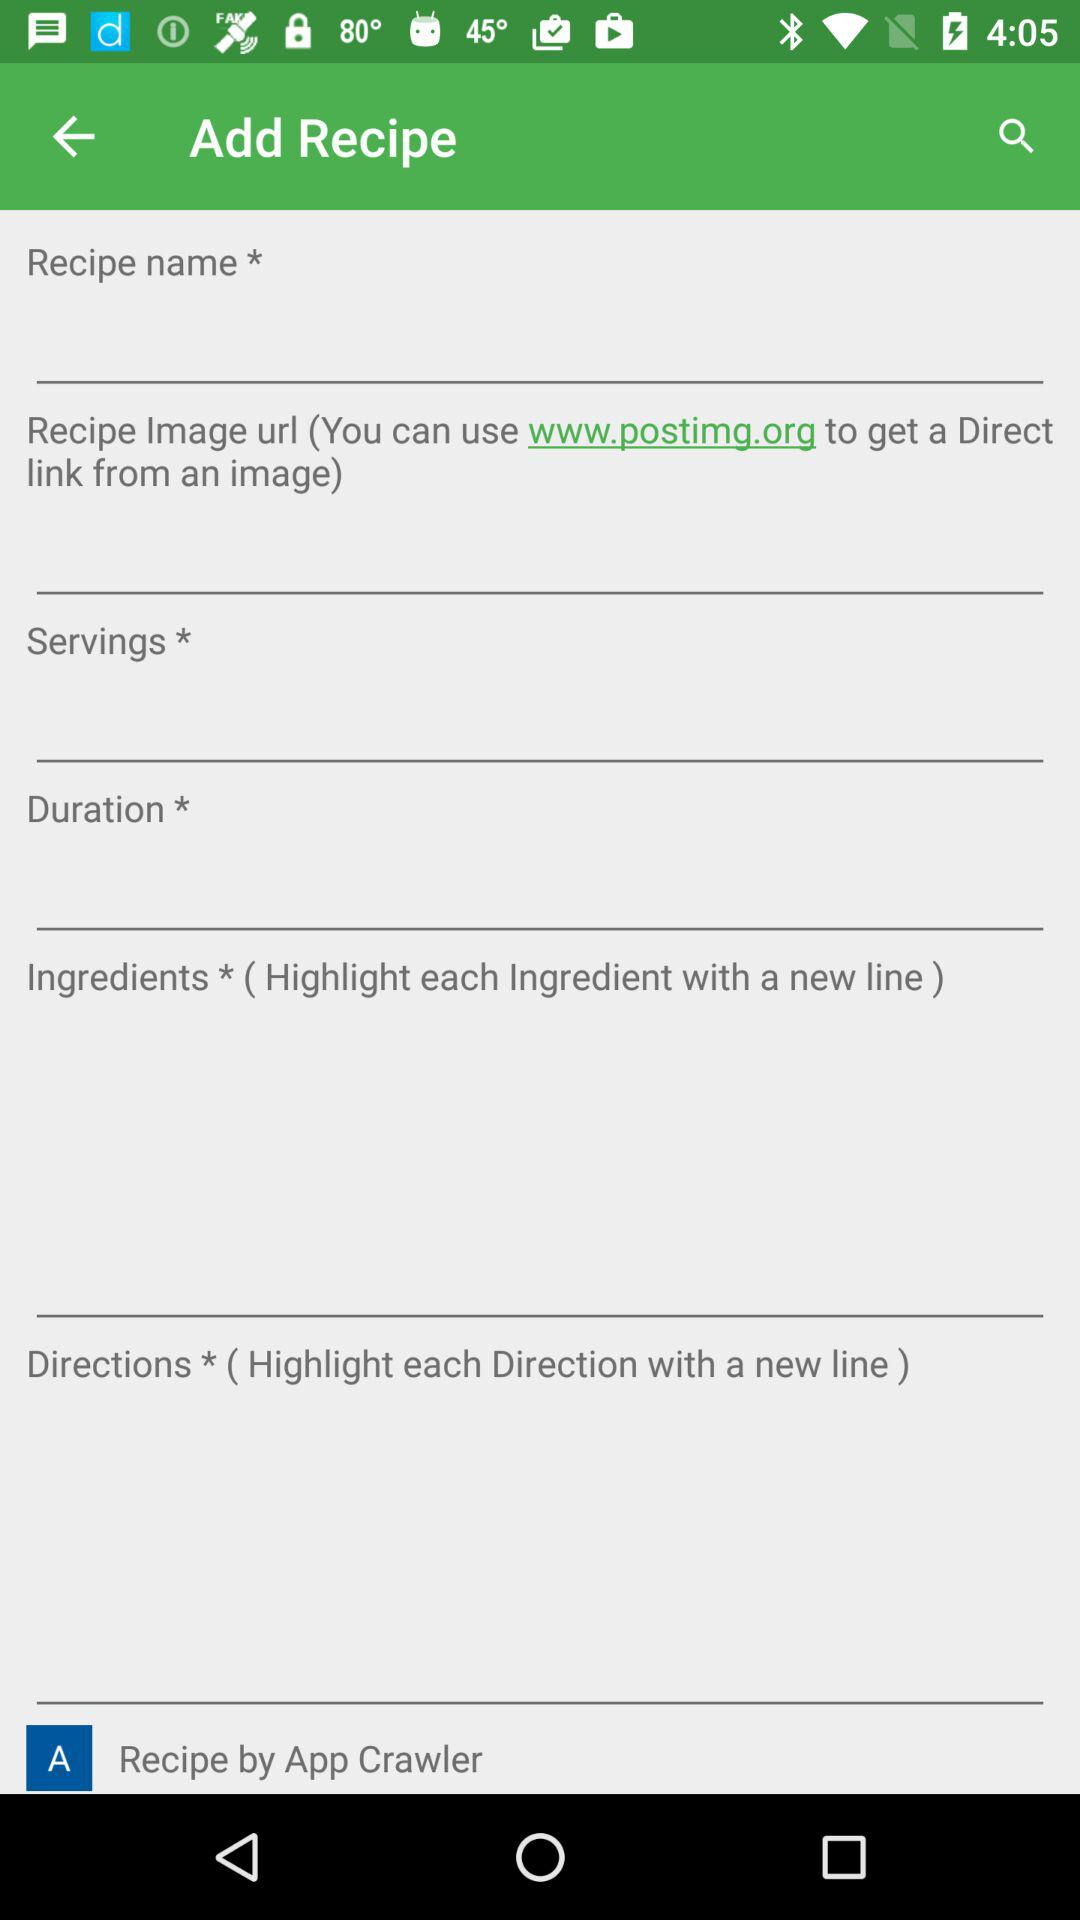What's the official website address used to get a direct link from an image? The official website address used to get a direct link from an image is www.postimg.org. 